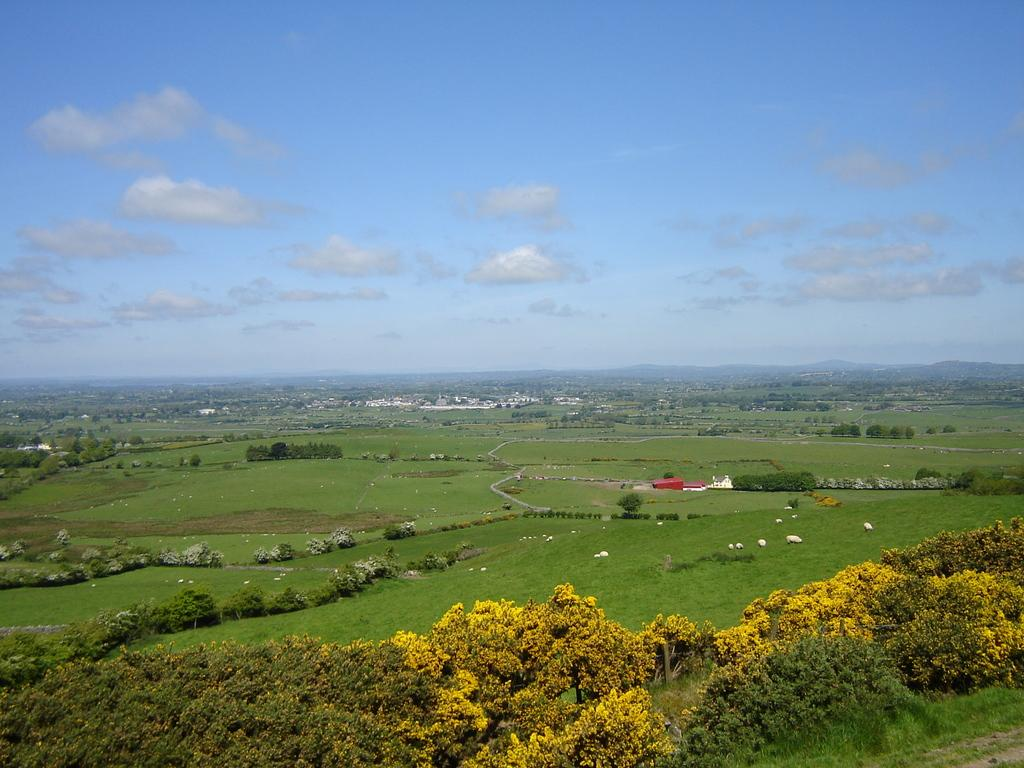What type of surface can be seen in the image? There is ground visible in the image. What type of vegetation is present in the image? There are trees in the image. What is visible in the background of the image? The sky is visible in the background of the image. What can be observed in the sky? Clouds are present in the sky. What type of mint is growing near the trees in the image? There is no mint present in the image; only trees are mentioned. What knowledge can be gained from observing the pig in the image? There is no pig present in the image, so no knowledge can be gained from observing it. 